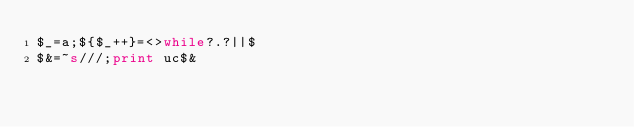<code> <loc_0><loc_0><loc_500><loc_500><_Perl_>$_=a;${$_++}=<>while?.?||$
$&=~s///;print uc$&</code> 